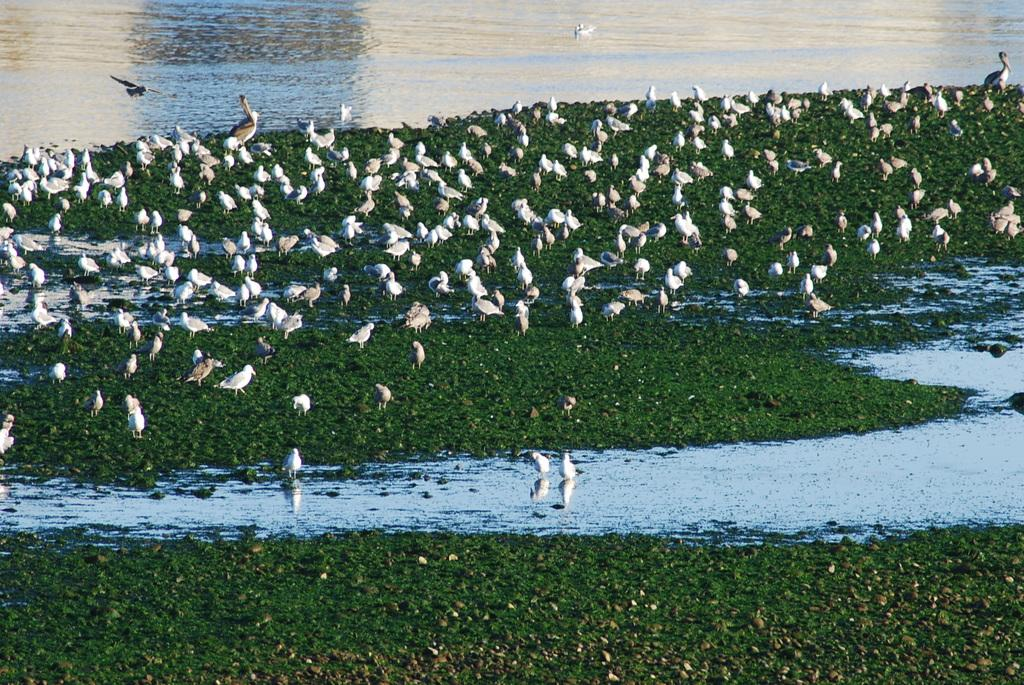What type of vegetation is visible in the image? There is grass in the image. What else can be seen in the image besides grass? There is water and birds visible in the image. What type of drug is being used by the birds in the image? There is no drug present in the image; it features grass, water, and birds. What type of volleyball court can be seen in the image? There is no volleyball court present in the image. 